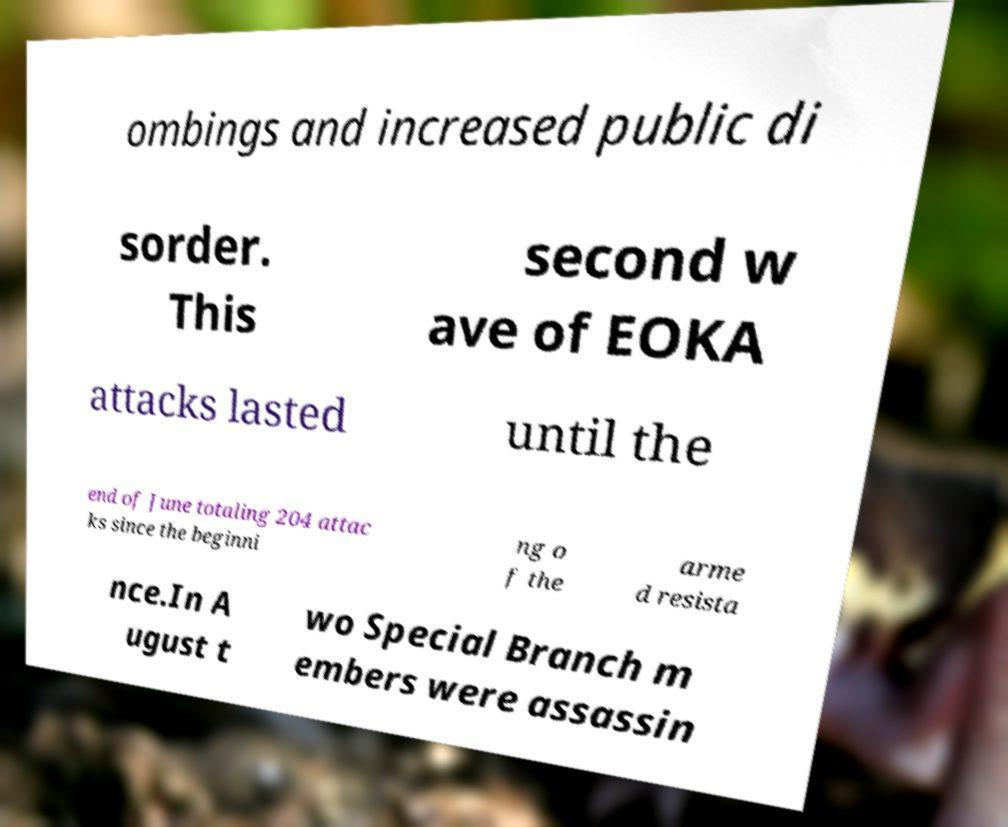There's text embedded in this image that I need extracted. Can you transcribe it verbatim? ombings and increased public di sorder. This second w ave of EOKA attacks lasted until the end of June totaling 204 attac ks since the beginni ng o f the arme d resista nce.In A ugust t wo Special Branch m embers were assassin 